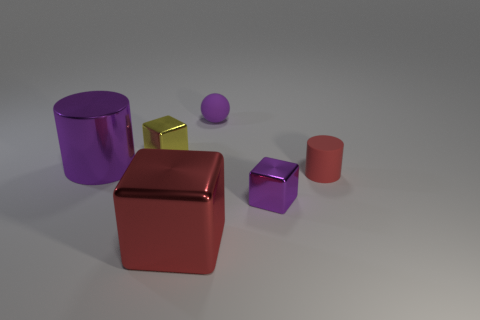What number of objects have the same color as the big metal cylinder?
Provide a succinct answer. 2. What is the color of the big shiny object that is left of the tiny yellow shiny thing?
Your response must be concise. Purple. What shape is the purple shiny thing that is the same size as the yellow object?
Provide a short and direct response. Cube. Is the color of the sphere the same as the small block to the left of the big red object?
Provide a succinct answer. No. What number of objects are purple metal things to the right of the red block or purple metallic objects on the left side of the purple rubber ball?
Provide a short and direct response. 2. There is a yellow thing that is the same size as the purple matte ball; what is its material?
Provide a succinct answer. Metal. How many other objects are the same material as the red cylinder?
Provide a succinct answer. 1. There is a rubber object that is on the left side of the small red object; does it have the same shape as the tiny purple object that is in front of the tiny red cylinder?
Your answer should be compact. No. There is a thing to the right of the tiny metallic thing that is on the right side of the block that is behind the matte cylinder; what is its color?
Offer a terse response. Red. What number of other things are the same color as the tiny sphere?
Provide a short and direct response. 2. 